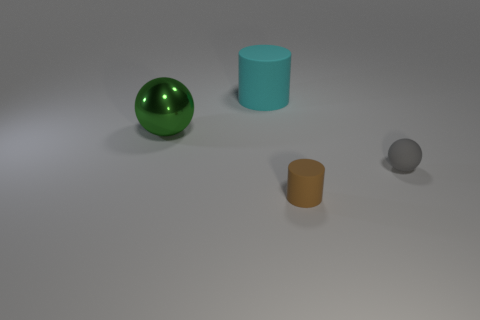Add 4 red blocks. How many objects exist? 8 Add 1 green objects. How many green objects are left? 2 Add 2 cyan cylinders. How many cyan cylinders exist? 3 Subtract 0 blue cylinders. How many objects are left? 4 Subtract all tiny gray rubber objects. Subtract all brown cylinders. How many objects are left? 2 